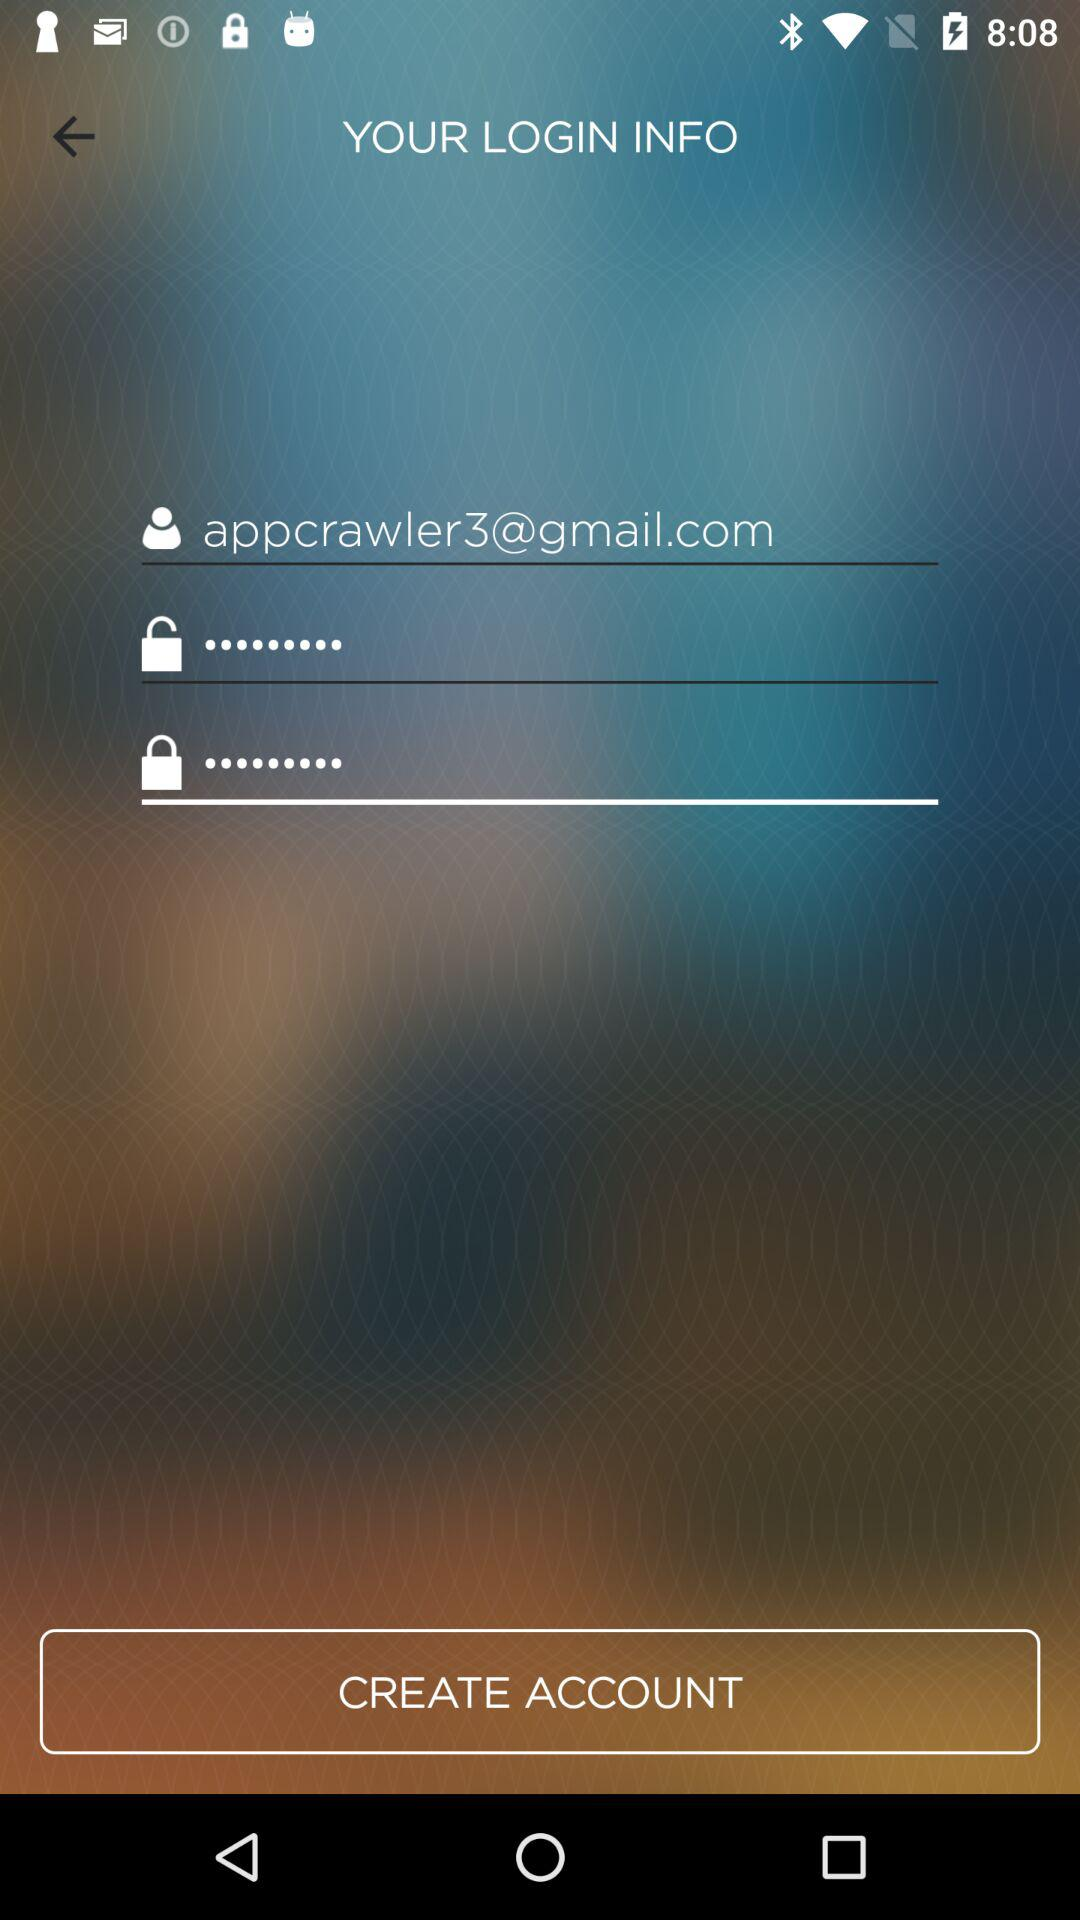What is the Gmail account? The Gmail account is appcrawler3@gmail.com. 